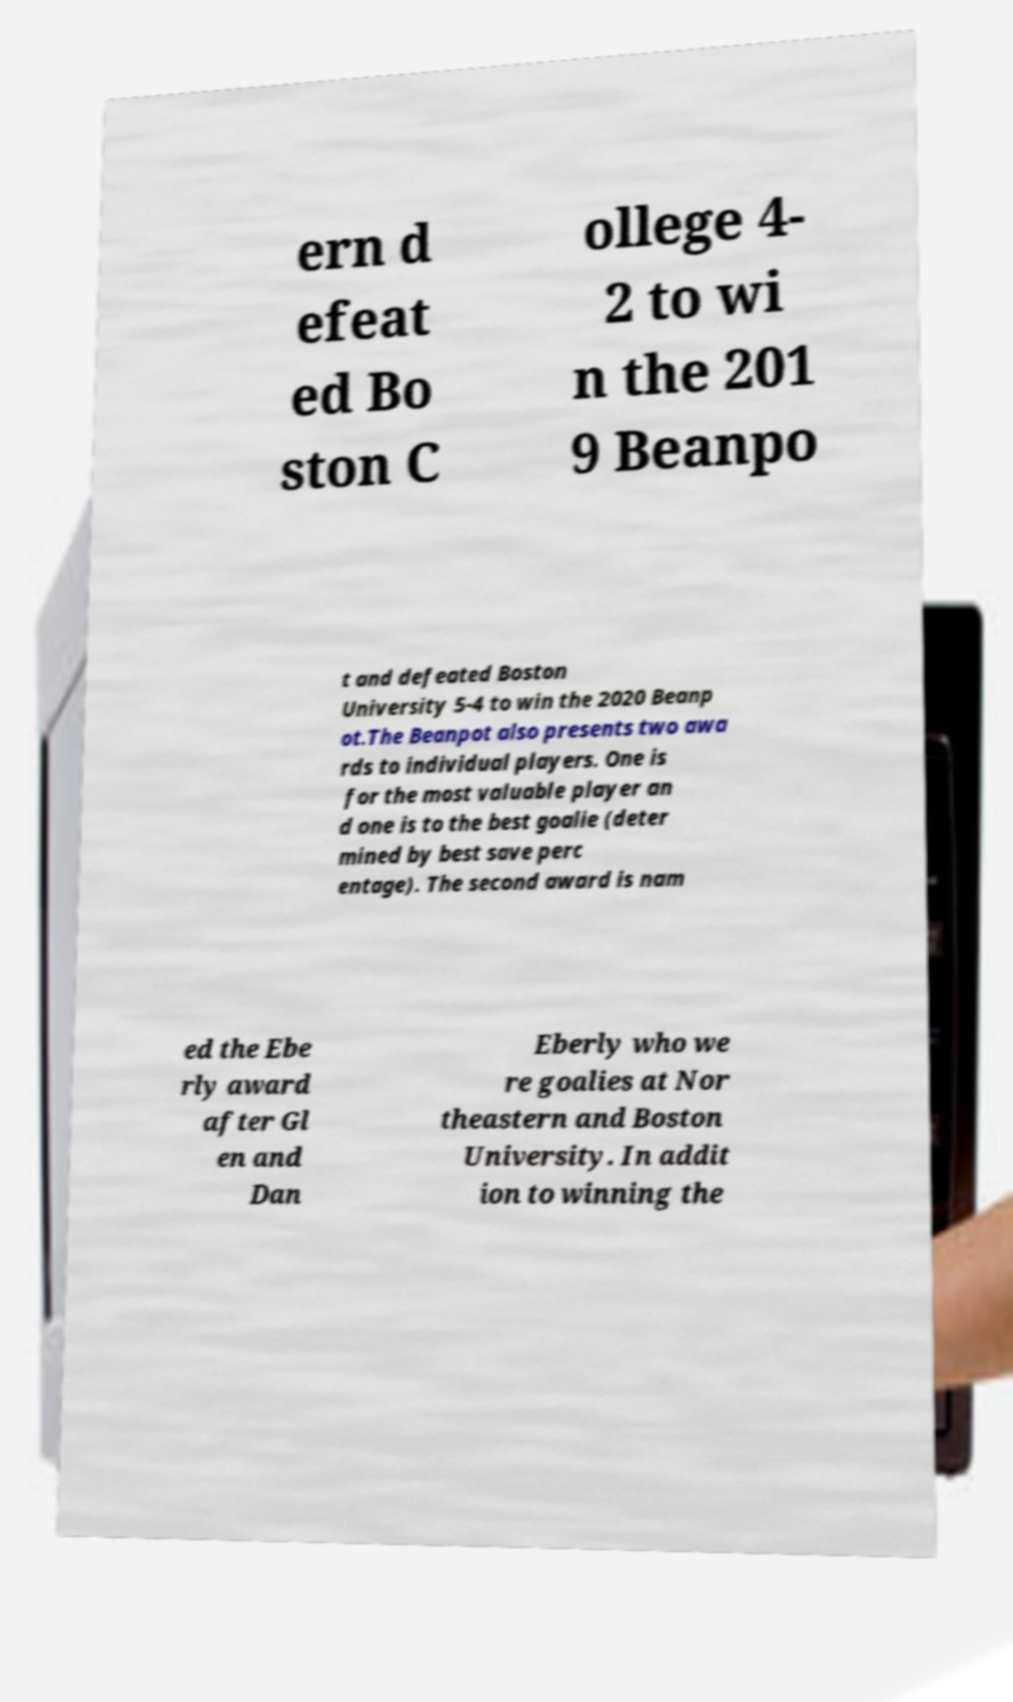For documentation purposes, I need the text within this image transcribed. Could you provide that? ern d efeat ed Bo ston C ollege 4- 2 to wi n the 201 9 Beanpo t and defeated Boston University 5-4 to win the 2020 Beanp ot.The Beanpot also presents two awa rds to individual players. One is for the most valuable player an d one is to the best goalie (deter mined by best save perc entage). The second award is nam ed the Ebe rly award after Gl en and Dan Eberly who we re goalies at Nor theastern and Boston University. In addit ion to winning the 